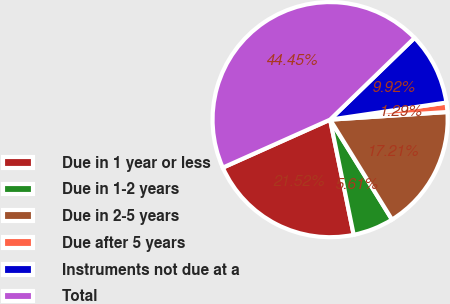Convert chart. <chart><loc_0><loc_0><loc_500><loc_500><pie_chart><fcel>Due in 1 year or less<fcel>Due in 1-2 years<fcel>Due in 2-5 years<fcel>Due after 5 years<fcel>Instruments not due at a<fcel>Total<nl><fcel>21.52%<fcel>5.61%<fcel>17.21%<fcel>1.29%<fcel>9.92%<fcel>44.45%<nl></chart> 